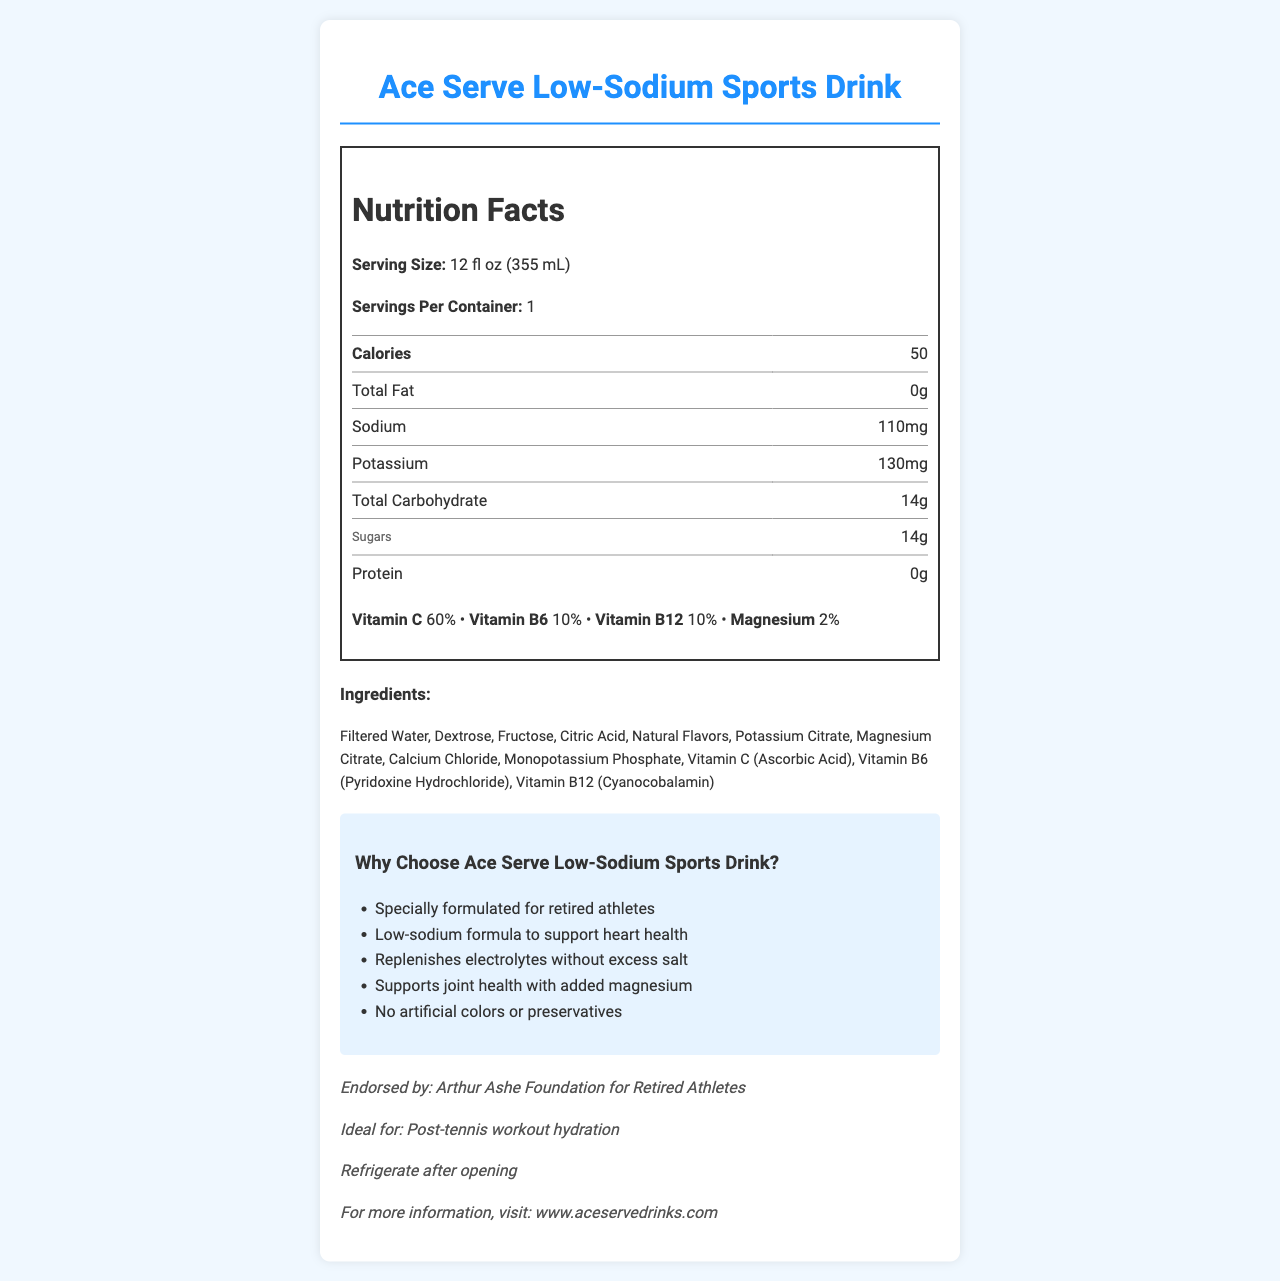who endorses the Ace Serve Low-Sodium Sports Drink? The document lists the Arthur Ashe Foundation for Retired Athletes as the endorsing organization.
Answer: Arthur Ashe Foundation for Retired Athletes how many calories are in one serving of the drink? The nutrition label specifies that one serving contains 50 calories.
Answer: 50 calories how much sugar is in the drink? According to the nutrition label, the drink contains 14 grams of sugar.
Answer: 14 grams which vitamins are included in this drink? The nutrition label mentions the presence of Vitamin C, Vitamin B6, and Vitamin B12.
Answer: Vitamin C, Vitamin B6, Vitamin B12 what is the flavor of the Ace Serve Low-Sodium Sports Drink? The flavor listed on the document is Wimbledon Strawberry.
Answer: Wimbledon Strawberry what is the serving size for the drink? The document states that the serving size is 12 fl oz (355 mL).
Answer: 12 fl oz (355 mL) how much sodium does the drink contain? The nutrition label shows that the drink contains 110 mg of sodium.
Answer: 110 mg what claim does the product make about joint health? One of the marketing claims is that the product supports joint health with added magnesium.
Answer: Supports joint health with added magnesium what is suggested to do with the drink after opening it? The document advises refrigerating the drink after opening.
Answer: Refrigerate after opening who specifically does not endorse the Ace Serve Low-Sodium Sports Drink? The document specifically mentions that the product is not endorsed by Guillermo Vilas.
Answer: Guillermo Vilas who is the target market for this sports drink? The marketing claims and additional information indicate that the target market is retired athletes.
Answer: Retired athletes what is the main purpose of the Ace Serve Low-Sodium Sports Drink as described in the marketing claims? The marketing claims emphasize the drink's role in replenishing electrolytes without excess salt and supporting heart and joint health.
Answer: To replenish electrolytes without excess salt and support heart and joint health which of the following ingredients is NOT listed in the drink? A. Filtered Water B. Sodium Chloride C. Fructose D. Potassium Citrate The ingredient list includes Filtered Water, Fructose, and Potassium Citrate, but not Sodium Chloride.
Answer: B how many servings are there per container? A. 1 B. 2 C. 3 D. 4 The document indicates that there is 1 serving per container.
Answer: A is the Ace Serve Low-Sodium Sports Drink suitable for post-tennis workout hydration? The additional information specifies that the drink is ideal for post-tennis workout hydration.
Answer: Yes can the amount of protein in the drink be determined from the document? The nutrition label explicitly states that the drink contains 0 grams of protein.
Answer: Yes, it is 0 grams summarize the main features and benefits of the Ace Serve Low-Sodium Sports Drink. This summary captures the key nutritional facts, intended audience, endorsed and non-endorsed entities, main flavor, and special benefits as outlined in the document.
Answer: The Ace Serve Low-Sodium Sports Drink is a 12 fl oz beverage with 50 calories and 14 grams of sugar. It contains essential vitamins such as Vitamin C, B6, and B12, as well as magnesium. The drink is particularly formulated for retired athletes, offering benefits such as low sodium for heart health, replenishment of electrolytes without excess salt, and support for joint health. It features natural ingredients and has no artificial colors or preservatives. It is endorsed by the Arthur Ashe Foundation for Retired Athletes but not by Guillermo Vilas. The flavor is Wimbledon Strawberry, and the drink should be refrigerated after opening. what is the source of Vitamin C in the drink? The document mentions Vitamin C (Ascorbic Acid) as an ingredient but does not specify its source.
Answer: Not enough information 